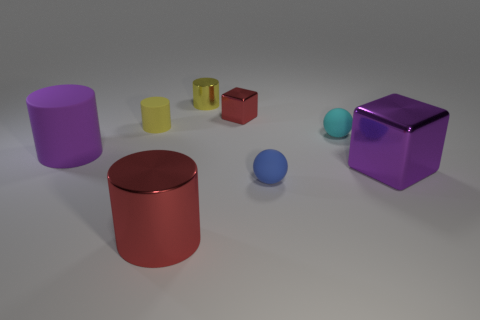Subtract all big purple cylinders. How many cylinders are left? 3 Subtract all purple cubes. How many yellow cylinders are left? 2 Subtract all yellow cylinders. How many cylinders are left? 2 Subtract 2 cylinders. How many cylinders are left? 2 Subtract all cubes. How many objects are left? 6 Add 1 gray cylinders. How many objects exist? 9 Add 3 big purple matte cylinders. How many big purple matte cylinders exist? 4 Subtract 0 blue cylinders. How many objects are left? 8 Subtract all yellow spheres. Subtract all gray cubes. How many spheres are left? 2 Subtract all large green rubber things. Subtract all purple cylinders. How many objects are left? 7 